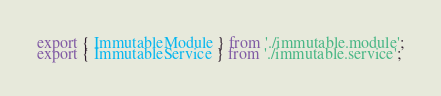Convert code to text. <code><loc_0><loc_0><loc_500><loc_500><_TypeScript_>export { ImmutableModule } from './immutable.module';
export { ImmutableService } from './immutable.service';</code> 